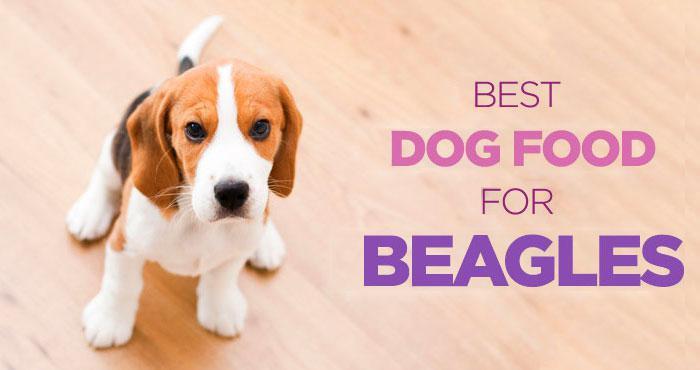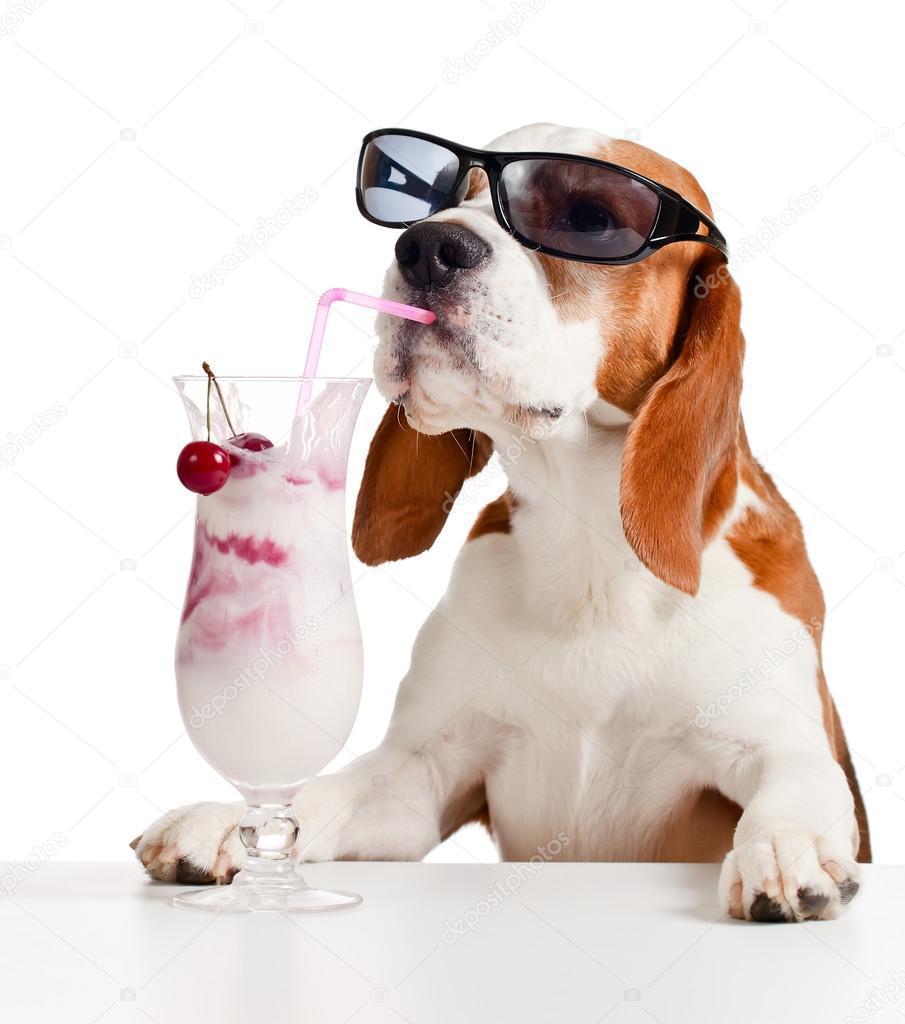The first image is the image on the left, the second image is the image on the right. Assess this claim about the two images: "The dog is looking left, in the image to the left.". Correct or not? Answer yes or no. No. The first image is the image on the left, the second image is the image on the right. For the images displayed, is the sentence "Two dogs are sitting." factually correct? Answer yes or no. No. 